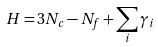Convert formula to latex. <formula><loc_0><loc_0><loc_500><loc_500>H = 3 N _ { c } - N _ { f } + \sum _ { i } \gamma _ { i }</formula> 